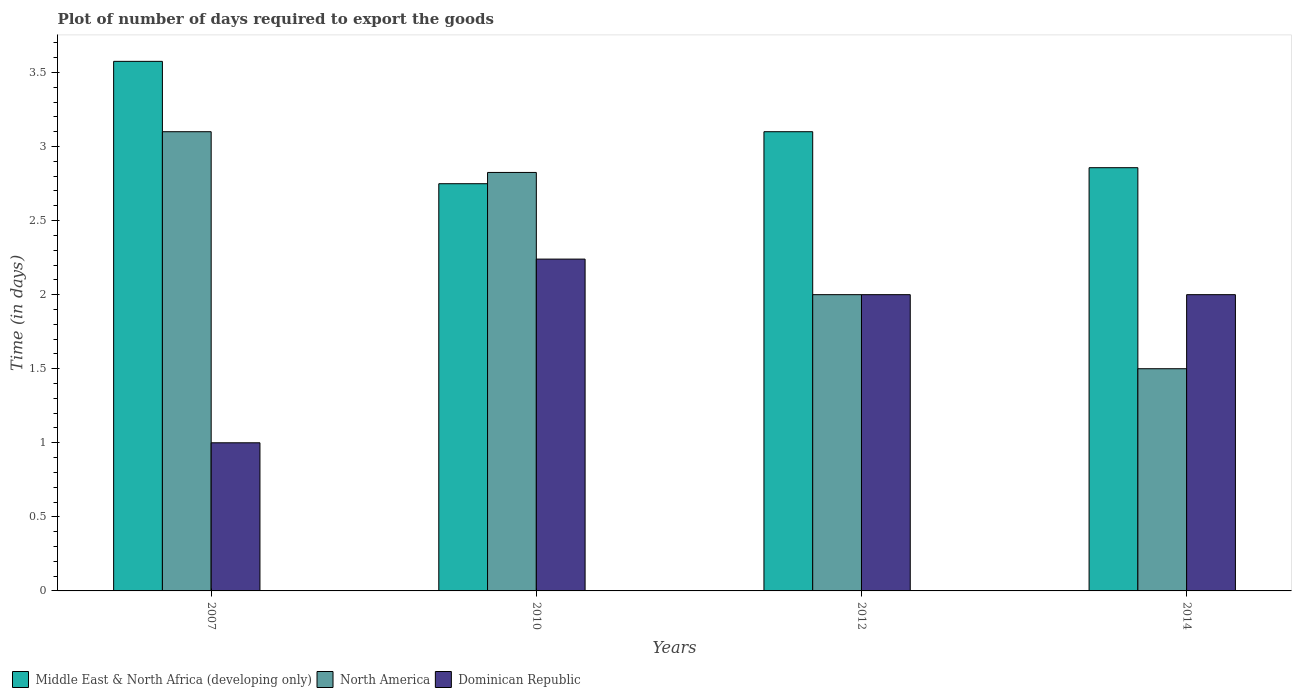How many different coloured bars are there?
Your response must be concise. 3. Are the number of bars per tick equal to the number of legend labels?
Keep it short and to the point. Yes. Are the number of bars on each tick of the X-axis equal?
Give a very brief answer. Yes. How many bars are there on the 2nd tick from the left?
Offer a very short reply. 3. What is the label of the 2nd group of bars from the left?
Your response must be concise. 2010. In how many cases, is the number of bars for a given year not equal to the number of legend labels?
Your answer should be compact. 0. What is the time required to export goods in Dominican Republic in 2007?
Provide a short and direct response. 1. Across all years, what is the maximum time required to export goods in North America?
Your answer should be very brief. 3.1. Across all years, what is the minimum time required to export goods in North America?
Keep it short and to the point. 1.5. In which year was the time required to export goods in Dominican Republic maximum?
Offer a very short reply. 2010. In which year was the time required to export goods in Middle East & North Africa (developing only) minimum?
Provide a short and direct response. 2010. What is the total time required to export goods in North America in the graph?
Give a very brief answer. 9.43. What is the difference between the time required to export goods in Middle East & North Africa (developing only) in 2007 and that in 2010?
Keep it short and to the point. 0.83. What is the difference between the time required to export goods in Middle East & North Africa (developing only) in 2010 and the time required to export goods in Dominican Republic in 2014?
Ensure brevity in your answer.  0.75. What is the average time required to export goods in North America per year?
Your answer should be very brief. 2.36. In the year 2007, what is the difference between the time required to export goods in North America and time required to export goods in Middle East & North Africa (developing only)?
Offer a terse response. -0.48. In how many years, is the time required to export goods in Middle East & North Africa (developing only) greater than 0.1 days?
Your answer should be very brief. 4. What is the ratio of the time required to export goods in Middle East & North Africa (developing only) in 2012 to that in 2014?
Give a very brief answer. 1.08. Is the time required to export goods in Middle East & North Africa (developing only) in 2010 less than that in 2012?
Ensure brevity in your answer.  Yes. Is the difference between the time required to export goods in North America in 2012 and 2014 greater than the difference between the time required to export goods in Middle East & North Africa (developing only) in 2012 and 2014?
Your response must be concise. Yes. What is the difference between the highest and the second highest time required to export goods in Middle East & North Africa (developing only)?
Make the answer very short. 0.48. What is the difference between the highest and the lowest time required to export goods in Dominican Republic?
Give a very brief answer. 1.24. Is the sum of the time required to export goods in North America in 2010 and 2012 greater than the maximum time required to export goods in Middle East & North Africa (developing only) across all years?
Offer a terse response. Yes. What does the 1st bar from the left in 2007 represents?
Your response must be concise. Middle East & North Africa (developing only). What does the 1st bar from the right in 2007 represents?
Offer a very short reply. Dominican Republic. How many bars are there?
Your answer should be very brief. 12. Are all the bars in the graph horizontal?
Keep it short and to the point. No. How many years are there in the graph?
Provide a succinct answer. 4. What is the difference between two consecutive major ticks on the Y-axis?
Offer a very short reply. 0.5. Does the graph contain grids?
Offer a very short reply. No. Where does the legend appear in the graph?
Your response must be concise. Bottom left. What is the title of the graph?
Ensure brevity in your answer.  Plot of number of days required to export the goods. Does "Central Europe" appear as one of the legend labels in the graph?
Make the answer very short. No. What is the label or title of the Y-axis?
Your response must be concise. Time (in days). What is the Time (in days) in Middle East & North Africa (developing only) in 2007?
Your answer should be very brief. 3.58. What is the Time (in days) in North America in 2007?
Provide a succinct answer. 3.1. What is the Time (in days) in Middle East & North Africa (developing only) in 2010?
Offer a very short reply. 2.75. What is the Time (in days) of North America in 2010?
Offer a terse response. 2.83. What is the Time (in days) in Dominican Republic in 2010?
Provide a short and direct response. 2.24. What is the Time (in days) in Dominican Republic in 2012?
Provide a short and direct response. 2. What is the Time (in days) of Middle East & North Africa (developing only) in 2014?
Provide a short and direct response. 2.86. Across all years, what is the maximum Time (in days) of Middle East & North Africa (developing only)?
Your answer should be compact. 3.58. Across all years, what is the maximum Time (in days) in North America?
Your answer should be compact. 3.1. Across all years, what is the maximum Time (in days) in Dominican Republic?
Keep it short and to the point. 2.24. Across all years, what is the minimum Time (in days) in Middle East & North Africa (developing only)?
Provide a succinct answer. 2.75. Across all years, what is the minimum Time (in days) of North America?
Your answer should be very brief. 1.5. Across all years, what is the minimum Time (in days) of Dominican Republic?
Give a very brief answer. 1. What is the total Time (in days) of Middle East & North Africa (developing only) in the graph?
Provide a short and direct response. 12.28. What is the total Time (in days) of North America in the graph?
Your answer should be compact. 9.43. What is the total Time (in days) in Dominican Republic in the graph?
Make the answer very short. 7.24. What is the difference between the Time (in days) of Middle East & North Africa (developing only) in 2007 and that in 2010?
Make the answer very short. 0.83. What is the difference between the Time (in days) in North America in 2007 and that in 2010?
Offer a very short reply. 0.28. What is the difference between the Time (in days) in Dominican Republic in 2007 and that in 2010?
Ensure brevity in your answer.  -1.24. What is the difference between the Time (in days) in Middle East & North Africa (developing only) in 2007 and that in 2012?
Your response must be concise. 0.47. What is the difference between the Time (in days) of Middle East & North Africa (developing only) in 2007 and that in 2014?
Give a very brief answer. 0.72. What is the difference between the Time (in days) of Middle East & North Africa (developing only) in 2010 and that in 2012?
Provide a short and direct response. -0.35. What is the difference between the Time (in days) of North America in 2010 and that in 2012?
Your response must be concise. 0.82. What is the difference between the Time (in days) in Dominican Republic in 2010 and that in 2012?
Your answer should be compact. 0.24. What is the difference between the Time (in days) of Middle East & North Africa (developing only) in 2010 and that in 2014?
Ensure brevity in your answer.  -0.11. What is the difference between the Time (in days) of North America in 2010 and that in 2014?
Your response must be concise. 1.32. What is the difference between the Time (in days) in Dominican Republic in 2010 and that in 2014?
Your response must be concise. 0.24. What is the difference between the Time (in days) in Middle East & North Africa (developing only) in 2012 and that in 2014?
Offer a very short reply. 0.24. What is the difference between the Time (in days) in North America in 2012 and that in 2014?
Offer a terse response. 0.5. What is the difference between the Time (in days) in Middle East & North Africa (developing only) in 2007 and the Time (in days) in Dominican Republic in 2010?
Your response must be concise. 1.33. What is the difference between the Time (in days) of North America in 2007 and the Time (in days) of Dominican Republic in 2010?
Your answer should be very brief. 0.86. What is the difference between the Time (in days) in Middle East & North Africa (developing only) in 2007 and the Time (in days) in North America in 2012?
Your response must be concise. 1.57. What is the difference between the Time (in days) of Middle East & North Africa (developing only) in 2007 and the Time (in days) of Dominican Republic in 2012?
Offer a terse response. 1.57. What is the difference between the Time (in days) in North America in 2007 and the Time (in days) in Dominican Republic in 2012?
Ensure brevity in your answer.  1.1. What is the difference between the Time (in days) in Middle East & North Africa (developing only) in 2007 and the Time (in days) in North America in 2014?
Give a very brief answer. 2.08. What is the difference between the Time (in days) of Middle East & North Africa (developing only) in 2007 and the Time (in days) of Dominican Republic in 2014?
Make the answer very short. 1.57. What is the difference between the Time (in days) in Middle East & North Africa (developing only) in 2010 and the Time (in days) in North America in 2012?
Your response must be concise. 0.75. What is the difference between the Time (in days) in Middle East & North Africa (developing only) in 2010 and the Time (in days) in Dominican Republic in 2012?
Make the answer very short. 0.75. What is the difference between the Time (in days) in North America in 2010 and the Time (in days) in Dominican Republic in 2012?
Give a very brief answer. 0.82. What is the difference between the Time (in days) of Middle East & North Africa (developing only) in 2010 and the Time (in days) of North America in 2014?
Keep it short and to the point. 1.25. What is the difference between the Time (in days) of Middle East & North Africa (developing only) in 2010 and the Time (in days) of Dominican Republic in 2014?
Offer a very short reply. 0.75. What is the difference between the Time (in days) of North America in 2010 and the Time (in days) of Dominican Republic in 2014?
Your answer should be very brief. 0.82. What is the difference between the Time (in days) of Middle East & North Africa (developing only) in 2012 and the Time (in days) of Dominican Republic in 2014?
Your response must be concise. 1.1. What is the difference between the Time (in days) in North America in 2012 and the Time (in days) in Dominican Republic in 2014?
Provide a succinct answer. 0. What is the average Time (in days) of Middle East & North Africa (developing only) per year?
Make the answer very short. 3.07. What is the average Time (in days) of North America per year?
Offer a terse response. 2.36. What is the average Time (in days) in Dominican Republic per year?
Provide a succinct answer. 1.81. In the year 2007, what is the difference between the Time (in days) in Middle East & North Africa (developing only) and Time (in days) in North America?
Offer a terse response. 0.47. In the year 2007, what is the difference between the Time (in days) in Middle East & North Africa (developing only) and Time (in days) in Dominican Republic?
Provide a short and direct response. 2.58. In the year 2007, what is the difference between the Time (in days) of North America and Time (in days) of Dominican Republic?
Your response must be concise. 2.1. In the year 2010, what is the difference between the Time (in days) in Middle East & North Africa (developing only) and Time (in days) in North America?
Offer a very short reply. -0.08. In the year 2010, what is the difference between the Time (in days) of Middle East & North Africa (developing only) and Time (in days) of Dominican Republic?
Your response must be concise. 0.51. In the year 2010, what is the difference between the Time (in days) of North America and Time (in days) of Dominican Republic?
Keep it short and to the point. 0.58. In the year 2012, what is the difference between the Time (in days) in Middle East & North Africa (developing only) and Time (in days) in North America?
Offer a terse response. 1.1. In the year 2012, what is the difference between the Time (in days) in Middle East & North Africa (developing only) and Time (in days) in Dominican Republic?
Ensure brevity in your answer.  1.1. In the year 2014, what is the difference between the Time (in days) in Middle East & North Africa (developing only) and Time (in days) in North America?
Keep it short and to the point. 1.36. What is the ratio of the Time (in days) in Middle East & North Africa (developing only) in 2007 to that in 2010?
Your answer should be very brief. 1.3. What is the ratio of the Time (in days) of North America in 2007 to that in 2010?
Your answer should be very brief. 1.1. What is the ratio of the Time (in days) of Dominican Republic in 2007 to that in 2010?
Your answer should be compact. 0.45. What is the ratio of the Time (in days) of Middle East & North Africa (developing only) in 2007 to that in 2012?
Offer a terse response. 1.15. What is the ratio of the Time (in days) of North America in 2007 to that in 2012?
Your answer should be compact. 1.55. What is the ratio of the Time (in days) in Dominican Republic in 2007 to that in 2012?
Offer a very short reply. 0.5. What is the ratio of the Time (in days) of Middle East & North Africa (developing only) in 2007 to that in 2014?
Give a very brief answer. 1.25. What is the ratio of the Time (in days) of North America in 2007 to that in 2014?
Offer a very short reply. 2.07. What is the ratio of the Time (in days) in Dominican Republic in 2007 to that in 2014?
Make the answer very short. 0.5. What is the ratio of the Time (in days) of Middle East & North Africa (developing only) in 2010 to that in 2012?
Ensure brevity in your answer.  0.89. What is the ratio of the Time (in days) of North America in 2010 to that in 2012?
Keep it short and to the point. 1.41. What is the ratio of the Time (in days) of Dominican Republic in 2010 to that in 2012?
Provide a short and direct response. 1.12. What is the ratio of the Time (in days) in Middle East & North Africa (developing only) in 2010 to that in 2014?
Your response must be concise. 0.96. What is the ratio of the Time (in days) in North America in 2010 to that in 2014?
Give a very brief answer. 1.88. What is the ratio of the Time (in days) in Dominican Republic in 2010 to that in 2014?
Your answer should be very brief. 1.12. What is the ratio of the Time (in days) of Middle East & North Africa (developing only) in 2012 to that in 2014?
Your response must be concise. 1.08. What is the ratio of the Time (in days) in North America in 2012 to that in 2014?
Make the answer very short. 1.33. What is the difference between the highest and the second highest Time (in days) in Middle East & North Africa (developing only)?
Provide a short and direct response. 0.47. What is the difference between the highest and the second highest Time (in days) of North America?
Keep it short and to the point. 0.28. What is the difference between the highest and the second highest Time (in days) of Dominican Republic?
Give a very brief answer. 0.24. What is the difference between the highest and the lowest Time (in days) in Middle East & North Africa (developing only)?
Make the answer very short. 0.83. What is the difference between the highest and the lowest Time (in days) in Dominican Republic?
Your answer should be compact. 1.24. 